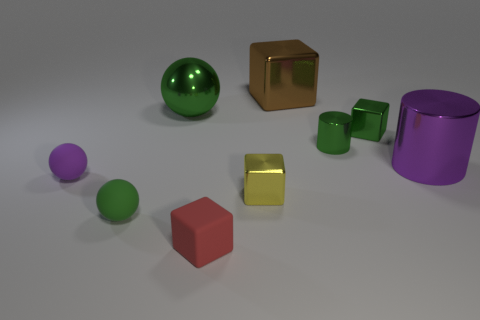Subtract 1 cubes. How many cubes are left? 3 Subtract all blue blocks. Subtract all yellow cylinders. How many blocks are left? 4 Subtract all blocks. How many objects are left? 5 Add 6 tiny green metallic things. How many tiny green metallic things exist? 8 Subtract 0 blue cubes. How many objects are left? 9 Subtract all yellow blocks. Subtract all large shiny cubes. How many objects are left? 7 Add 4 red matte cubes. How many red matte cubes are left? 5 